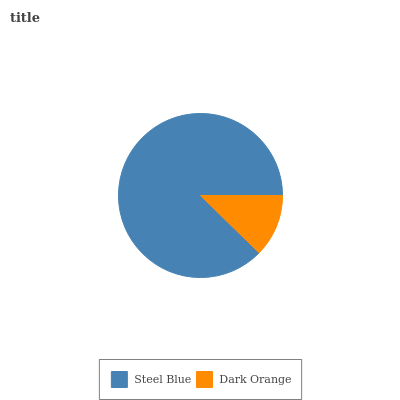Is Dark Orange the minimum?
Answer yes or no. Yes. Is Steel Blue the maximum?
Answer yes or no. Yes. Is Dark Orange the maximum?
Answer yes or no. No. Is Steel Blue greater than Dark Orange?
Answer yes or no. Yes. Is Dark Orange less than Steel Blue?
Answer yes or no. Yes. Is Dark Orange greater than Steel Blue?
Answer yes or no. No. Is Steel Blue less than Dark Orange?
Answer yes or no. No. Is Steel Blue the high median?
Answer yes or no. Yes. Is Dark Orange the low median?
Answer yes or no. Yes. Is Dark Orange the high median?
Answer yes or no. No. Is Steel Blue the low median?
Answer yes or no. No. 